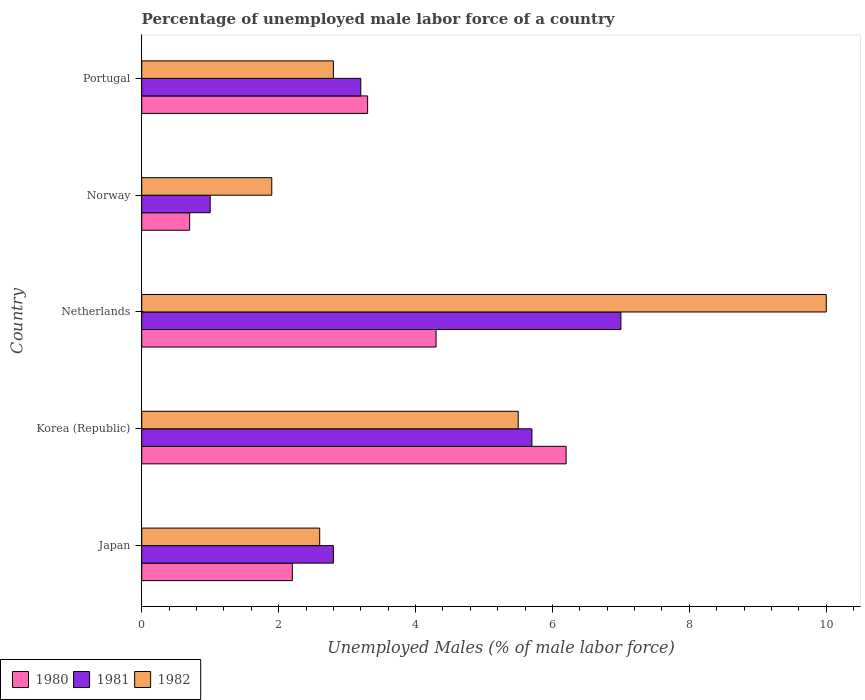How many different coloured bars are there?
Keep it short and to the point. 3. How many groups of bars are there?
Your answer should be very brief. 5. Are the number of bars per tick equal to the number of legend labels?
Offer a terse response. Yes. Are the number of bars on each tick of the Y-axis equal?
Give a very brief answer. Yes. How many bars are there on the 4th tick from the top?
Your response must be concise. 3. In how many cases, is the number of bars for a given country not equal to the number of legend labels?
Give a very brief answer. 0. What is the percentage of unemployed male labor force in 1982 in Portugal?
Provide a succinct answer. 2.8. Across all countries, what is the minimum percentage of unemployed male labor force in 1982?
Give a very brief answer. 1.9. In which country was the percentage of unemployed male labor force in 1982 maximum?
Provide a short and direct response. Netherlands. What is the total percentage of unemployed male labor force in 1982 in the graph?
Provide a short and direct response. 22.8. What is the difference between the percentage of unemployed male labor force in 1982 in Japan and that in Korea (Republic)?
Ensure brevity in your answer.  -2.9. What is the difference between the percentage of unemployed male labor force in 1980 in Norway and the percentage of unemployed male labor force in 1982 in Korea (Republic)?
Your response must be concise. -4.8. What is the average percentage of unemployed male labor force in 1982 per country?
Offer a terse response. 4.56. What is the difference between the percentage of unemployed male labor force in 1981 and percentage of unemployed male labor force in 1980 in Norway?
Provide a succinct answer. 0.3. What is the ratio of the percentage of unemployed male labor force in 1982 in Japan to that in Norway?
Make the answer very short. 1.37. Is the difference between the percentage of unemployed male labor force in 1981 in Korea (Republic) and Norway greater than the difference between the percentage of unemployed male labor force in 1980 in Korea (Republic) and Norway?
Give a very brief answer. No. What is the difference between the highest and the second highest percentage of unemployed male labor force in 1982?
Offer a terse response. 4.5. What is the difference between the highest and the lowest percentage of unemployed male labor force in 1980?
Offer a very short reply. 5.5. In how many countries, is the percentage of unemployed male labor force in 1980 greater than the average percentage of unemployed male labor force in 1980 taken over all countries?
Keep it short and to the point. 2. Is the sum of the percentage of unemployed male labor force in 1980 in Norway and Portugal greater than the maximum percentage of unemployed male labor force in 1981 across all countries?
Provide a succinct answer. No. What does the 2nd bar from the top in Netherlands represents?
Provide a short and direct response. 1981. How many bars are there?
Provide a short and direct response. 15. What is the difference between two consecutive major ticks on the X-axis?
Your answer should be compact. 2. Are the values on the major ticks of X-axis written in scientific E-notation?
Ensure brevity in your answer.  No. Does the graph contain any zero values?
Give a very brief answer. No. Does the graph contain grids?
Your response must be concise. No. Where does the legend appear in the graph?
Give a very brief answer. Bottom left. How many legend labels are there?
Keep it short and to the point. 3. What is the title of the graph?
Keep it short and to the point. Percentage of unemployed male labor force of a country. Does "1972" appear as one of the legend labels in the graph?
Ensure brevity in your answer.  No. What is the label or title of the X-axis?
Offer a terse response. Unemployed Males (% of male labor force). What is the label or title of the Y-axis?
Give a very brief answer. Country. What is the Unemployed Males (% of male labor force) of 1980 in Japan?
Offer a very short reply. 2.2. What is the Unemployed Males (% of male labor force) of 1981 in Japan?
Ensure brevity in your answer.  2.8. What is the Unemployed Males (% of male labor force) in 1982 in Japan?
Make the answer very short. 2.6. What is the Unemployed Males (% of male labor force) of 1980 in Korea (Republic)?
Offer a very short reply. 6.2. What is the Unemployed Males (% of male labor force) of 1981 in Korea (Republic)?
Keep it short and to the point. 5.7. What is the Unemployed Males (% of male labor force) in 1980 in Netherlands?
Make the answer very short. 4.3. What is the Unemployed Males (% of male labor force) in 1981 in Netherlands?
Your answer should be compact. 7. What is the Unemployed Males (% of male labor force) in 1982 in Netherlands?
Ensure brevity in your answer.  10. What is the Unemployed Males (% of male labor force) of 1980 in Norway?
Your answer should be compact. 0.7. What is the Unemployed Males (% of male labor force) in 1981 in Norway?
Make the answer very short. 1. What is the Unemployed Males (% of male labor force) of 1982 in Norway?
Offer a terse response. 1.9. What is the Unemployed Males (% of male labor force) in 1980 in Portugal?
Provide a succinct answer. 3.3. What is the Unemployed Males (% of male labor force) in 1981 in Portugal?
Your answer should be very brief. 3.2. What is the Unemployed Males (% of male labor force) of 1982 in Portugal?
Provide a short and direct response. 2.8. Across all countries, what is the maximum Unemployed Males (% of male labor force) in 1980?
Your answer should be very brief. 6.2. Across all countries, what is the maximum Unemployed Males (% of male labor force) of 1982?
Make the answer very short. 10. Across all countries, what is the minimum Unemployed Males (% of male labor force) in 1980?
Offer a terse response. 0.7. Across all countries, what is the minimum Unemployed Males (% of male labor force) in 1982?
Provide a short and direct response. 1.9. What is the total Unemployed Males (% of male labor force) in 1981 in the graph?
Give a very brief answer. 19.7. What is the total Unemployed Males (% of male labor force) of 1982 in the graph?
Make the answer very short. 22.8. What is the difference between the Unemployed Males (% of male labor force) in 1980 in Japan and that in Netherlands?
Provide a succinct answer. -2.1. What is the difference between the Unemployed Males (% of male labor force) of 1981 in Japan and that in Netherlands?
Your response must be concise. -4.2. What is the difference between the Unemployed Males (% of male labor force) of 1982 in Japan and that in Netherlands?
Offer a terse response. -7.4. What is the difference between the Unemployed Males (% of male labor force) in 1980 in Japan and that in Norway?
Keep it short and to the point. 1.5. What is the difference between the Unemployed Males (% of male labor force) in 1981 in Japan and that in Norway?
Give a very brief answer. 1.8. What is the difference between the Unemployed Males (% of male labor force) of 1982 in Japan and that in Norway?
Provide a succinct answer. 0.7. What is the difference between the Unemployed Males (% of male labor force) in 1980 in Korea (Republic) and that in Netherlands?
Ensure brevity in your answer.  1.9. What is the difference between the Unemployed Males (% of male labor force) in 1981 in Korea (Republic) and that in Netherlands?
Your answer should be compact. -1.3. What is the difference between the Unemployed Males (% of male labor force) of 1982 in Korea (Republic) and that in Netherlands?
Provide a succinct answer. -4.5. What is the difference between the Unemployed Males (% of male labor force) in 1981 in Korea (Republic) and that in Norway?
Your response must be concise. 4.7. What is the difference between the Unemployed Males (% of male labor force) of 1982 in Korea (Republic) and that in Norway?
Keep it short and to the point. 3.6. What is the difference between the Unemployed Males (% of male labor force) in 1980 in Korea (Republic) and that in Portugal?
Offer a terse response. 2.9. What is the difference between the Unemployed Males (% of male labor force) of 1982 in Korea (Republic) and that in Portugal?
Your answer should be very brief. 2.7. What is the difference between the Unemployed Males (% of male labor force) in 1980 in Netherlands and that in Norway?
Provide a short and direct response. 3.6. What is the difference between the Unemployed Males (% of male labor force) of 1981 in Netherlands and that in Norway?
Offer a terse response. 6. What is the difference between the Unemployed Males (% of male labor force) in 1982 in Netherlands and that in Portugal?
Offer a terse response. 7.2. What is the difference between the Unemployed Males (% of male labor force) of 1980 in Norway and that in Portugal?
Your answer should be very brief. -2.6. What is the difference between the Unemployed Males (% of male labor force) of 1981 in Norway and that in Portugal?
Provide a short and direct response. -2.2. What is the difference between the Unemployed Males (% of male labor force) in 1982 in Norway and that in Portugal?
Your response must be concise. -0.9. What is the difference between the Unemployed Males (% of male labor force) in 1980 in Japan and the Unemployed Males (% of male labor force) in 1981 in Korea (Republic)?
Offer a very short reply. -3.5. What is the difference between the Unemployed Males (% of male labor force) in 1980 in Japan and the Unemployed Males (% of male labor force) in 1982 in Korea (Republic)?
Make the answer very short. -3.3. What is the difference between the Unemployed Males (% of male labor force) of 1980 in Japan and the Unemployed Males (% of male labor force) of 1981 in Netherlands?
Give a very brief answer. -4.8. What is the difference between the Unemployed Males (% of male labor force) in 1980 in Japan and the Unemployed Males (% of male labor force) in 1982 in Norway?
Your response must be concise. 0.3. What is the difference between the Unemployed Males (% of male labor force) of 1980 in Japan and the Unemployed Males (% of male labor force) of 1981 in Portugal?
Your response must be concise. -1. What is the difference between the Unemployed Males (% of male labor force) of 1981 in Japan and the Unemployed Males (% of male labor force) of 1982 in Portugal?
Your answer should be compact. 0. What is the difference between the Unemployed Males (% of male labor force) in 1980 in Korea (Republic) and the Unemployed Males (% of male labor force) in 1982 in Netherlands?
Your response must be concise. -3.8. What is the difference between the Unemployed Males (% of male labor force) of 1980 in Korea (Republic) and the Unemployed Males (% of male labor force) of 1982 in Norway?
Give a very brief answer. 4.3. What is the difference between the Unemployed Males (% of male labor force) of 1981 in Korea (Republic) and the Unemployed Males (% of male labor force) of 1982 in Norway?
Your response must be concise. 3.8. What is the difference between the Unemployed Males (% of male labor force) in 1980 in Korea (Republic) and the Unemployed Males (% of male labor force) in 1981 in Portugal?
Your answer should be compact. 3. What is the difference between the Unemployed Males (% of male labor force) of 1980 in Netherlands and the Unemployed Males (% of male labor force) of 1981 in Norway?
Give a very brief answer. 3.3. What is the difference between the Unemployed Males (% of male labor force) in 1980 in Netherlands and the Unemployed Males (% of male labor force) in 1982 in Norway?
Your answer should be compact. 2.4. What is the difference between the Unemployed Males (% of male labor force) of 1981 in Netherlands and the Unemployed Males (% of male labor force) of 1982 in Norway?
Provide a succinct answer. 5.1. What is the difference between the Unemployed Males (% of male labor force) of 1980 in Netherlands and the Unemployed Males (% of male labor force) of 1982 in Portugal?
Give a very brief answer. 1.5. What is the difference between the Unemployed Males (% of male labor force) of 1981 in Netherlands and the Unemployed Males (% of male labor force) of 1982 in Portugal?
Make the answer very short. 4.2. What is the difference between the Unemployed Males (% of male labor force) in 1980 in Norway and the Unemployed Males (% of male labor force) in 1981 in Portugal?
Provide a succinct answer. -2.5. What is the difference between the Unemployed Males (% of male labor force) in 1981 in Norway and the Unemployed Males (% of male labor force) in 1982 in Portugal?
Make the answer very short. -1.8. What is the average Unemployed Males (% of male labor force) of 1980 per country?
Your answer should be very brief. 3.34. What is the average Unemployed Males (% of male labor force) in 1981 per country?
Your answer should be compact. 3.94. What is the average Unemployed Males (% of male labor force) of 1982 per country?
Give a very brief answer. 4.56. What is the difference between the Unemployed Males (% of male labor force) in 1980 and Unemployed Males (% of male labor force) in 1982 in Japan?
Make the answer very short. -0.4. What is the difference between the Unemployed Males (% of male labor force) of 1981 and Unemployed Males (% of male labor force) of 1982 in Japan?
Offer a very short reply. 0.2. What is the difference between the Unemployed Males (% of male labor force) in 1980 and Unemployed Males (% of male labor force) in 1982 in Korea (Republic)?
Ensure brevity in your answer.  0.7. What is the difference between the Unemployed Males (% of male labor force) in 1980 and Unemployed Males (% of male labor force) in 1981 in Netherlands?
Give a very brief answer. -2.7. What is the difference between the Unemployed Males (% of male labor force) of 1980 and Unemployed Males (% of male labor force) of 1982 in Netherlands?
Keep it short and to the point. -5.7. What is the difference between the Unemployed Males (% of male labor force) in 1980 and Unemployed Males (% of male labor force) in 1981 in Norway?
Provide a short and direct response. -0.3. What is the difference between the Unemployed Males (% of male labor force) in 1981 and Unemployed Males (% of male labor force) in 1982 in Norway?
Offer a very short reply. -0.9. What is the difference between the Unemployed Males (% of male labor force) of 1981 and Unemployed Males (% of male labor force) of 1982 in Portugal?
Give a very brief answer. 0.4. What is the ratio of the Unemployed Males (% of male labor force) in 1980 in Japan to that in Korea (Republic)?
Ensure brevity in your answer.  0.35. What is the ratio of the Unemployed Males (% of male labor force) of 1981 in Japan to that in Korea (Republic)?
Offer a terse response. 0.49. What is the ratio of the Unemployed Males (% of male labor force) in 1982 in Japan to that in Korea (Republic)?
Your answer should be compact. 0.47. What is the ratio of the Unemployed Males (% of male labor force) in 1980 in Japan to that in Netherlands?
Make the answer very short. 0.51. What is the ratio of the Unemployed Males (% of male labor force) in 1981 in Japan to that in Netherlands?
Provide a succinct answer. 0.4. What is the ratio of the Unemployed Males (% of male labor force) of 1982 in Japan to that in Netherlands?
Give a very brief answer. 0.26. What is the ratio of the Unemployed Males (% of male labor force) of 1980 in Japan to that in Norway?
Ensure brevity in your answer.  3.14. What is the ratio of the Unemployed Males (% of male labor force) of 1981 in Japan to that in Norway?
Give a very brief answer. 2.8. What is the ratio of the Unemployed Males (% of male labor force) in 1982 in Japan to that in Norway?
Your answer should be compact. 1.37. What is the ratio of the Unemployed Males (% of male labor force) of 1980 in Japan to that in Portugal?
Your response must be concise. 0.67. What is the ratio of the Unemployed Males (% of male labor force) in 1981 in Japan to that in Portugal?
Keep it short and to the point. 0.88. What is the ratio of the Unemployed Males (% of male labor force) in 1980 in Korea (Republic) to that in Netherlands?
Make the answer very short. 1.44. What is the ratio of the Unemployed Males (% of male labor force) of 1981 in Korea (Republic) to that in Netherlands?
Your response must be concise. 0.81. What is the ratio of the Unemployed Males (% of male labor force) in 1982 in Korea (Republic) to that in Netherlands?
Your response must be concise. 0.55. What is the ratio of the Unemployed Males (% of male labor force) of 1980 in Korea (Republic) to that in Norway?
Offer a very short reply. 8.86. What is the ratio of the Unemployed Males (% of male labor force) in 1981 in Korea (Republic) to that in Norway?
Your response must be concise. 5.7. What is the ratio of the Unemployed Males (% of male labor force) in 1982 in Korea (Republic) to that in Norway?
Keep it short and to the point. 2.89. What is the ratio of the Unemployed Males (% of male labor force) of 1980 in Korea (Republic) to that in Portugal?
Keep it short and to the point. 1.88. What is the ratio of the Unemployed Males (% of male labor force) in 1981 in Korea (Republic) to that in Portugal?
Offer a very short reply. 1.78. What is the ratio of the Unemployed Males (% of male labor force) of 1982 in Korea (Republic) to that in Portugal?
Make the answer very short. 1.96. What is the ratio of the Unemployed Males (% of male labor force) in 1980 in Netherlands to that in Norway?
Your answer should be compact. 6.14. What is the ratio of the Unemployed Males (% of male labor force) in 1981 in Netherlands to that in Norway?
Your answer should be very brief. 7. What is the ratio of the Unemployed Males (% of male labor force) of 1982 in Netherlands to that in Norway?
Offer a very short reply. 5.26. What is the ratio of the Unemployed Males (% of male labor force) of 1980 in Netherlands to that in Portugal?
Your response must be concise. 1.3. What is the ratio of the Unemployed Males (% of male labor force) in 1981 in Netherlands to that in Portugal?
Give a very brief answer. 2.19. What is the ratio of the Unemployed Males (% of male labor force) of 1982 in Netherlands to that in Portugal?
Offer a terse response. 3.57. What is the ratio of the Unemployed Males (% of male labor force) of 1980 in Norway to that in Portugal?
Provide a short and direct response. 0.21. What is the ratio of the Unemployed Males (% of male labor force) of 1981 in Norway to that in Portugal?
Provide a short and direct response. 0.31. What is the ratio of the Unemployed Males (% of male labor force) of 1982 in Norway to that in Portugal?
Ensure brevity in your answer.  0.68. What is the difference between the highest and the second highest Unemployed Males (% of male labor force) of 1980?
Offer a terse response. 1.9. What is the difference between the highest and the second highest Unemployed Males (% of male labor force) in 1981?
Offer a very short reply. 1.3. What is the difference between the highest and the second highest Unemployed Males (% of male labor force) in 1982?
Provide a succinct answer. 4.5. What is the difference between the highest and the lowest Unemployed Males (% of male labor force) of 1980?
Provide a short and direct response. 5.5. What is the difference between the highest and the lowest Unemployed Males (% of male labor force) of 1981?
Your response must be concise. 6. 